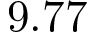Convert formula to latex. <formula><loc_0><loc_0><loc_500><loc_500>9 . 7 7</formula> 